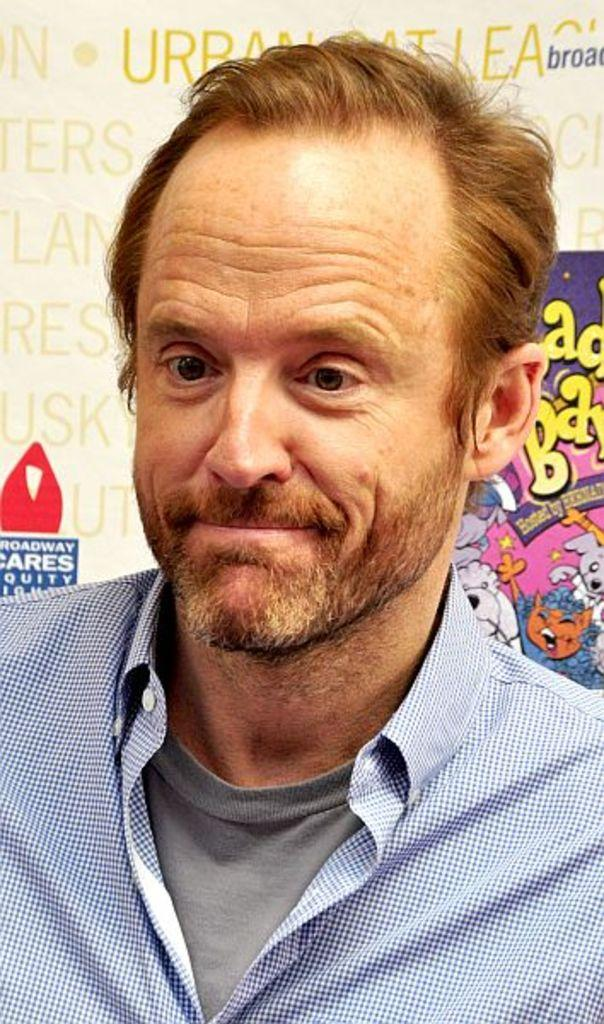Who is present in the image? There is a man in the image. What is the man doing in the image? The man is smiling in the image. What is the man wearing in the image? The man is wearing a T-shirt and a shirt in the image. What can be seen in the background of the image? There is a poster in the background of the image. What is featured on the poster? The poster has letters and pictures on it. Is the man driving a car in the image? No, there is no car or driving activity depicted in the image. What type of porter is assisting the man in the image? There is no porter present in the image; the man is alone. 